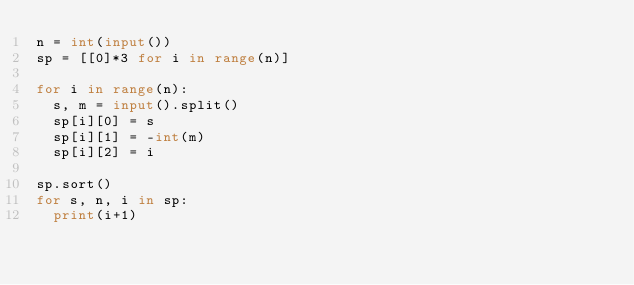<code> <loc_0><loc_0><loc_500><loc_500><_Python_>n = int(input())
sp = [[0]*3 for i in range(n)]

for i in range(n):
  s, m = input().split()
  sp[i][0] = s
  sp[i][1] = -int(m)
  sp[i][2] = i

sp.sort()
for s, n, i in sp:
  print(i+1)</code> 